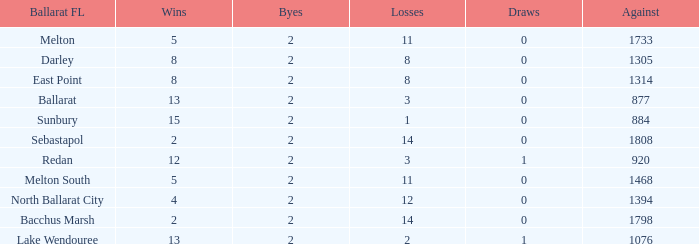How many Byes have Against of 1076 and Wins smaller than 13? None. 